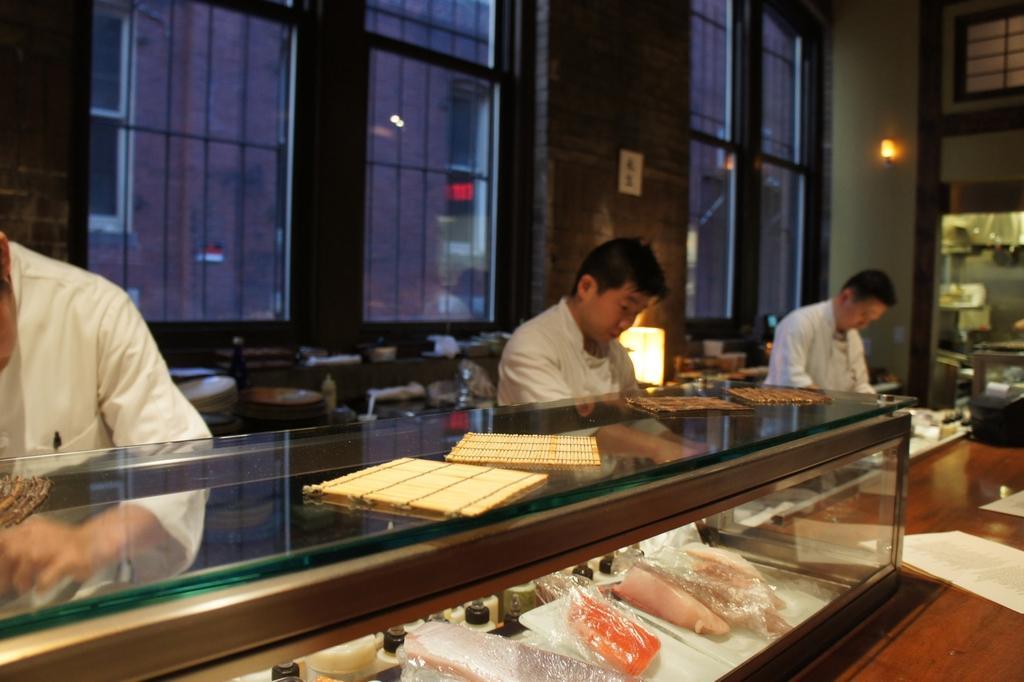Can you describe this image briefly? Here in this picture we can see three men standing in white apron in front of a table and they are preparing food, as we can see the rack with food in the front and behind them we can see windows of the building and through the building we can see another buildings, we can see lights on wall here and there. 